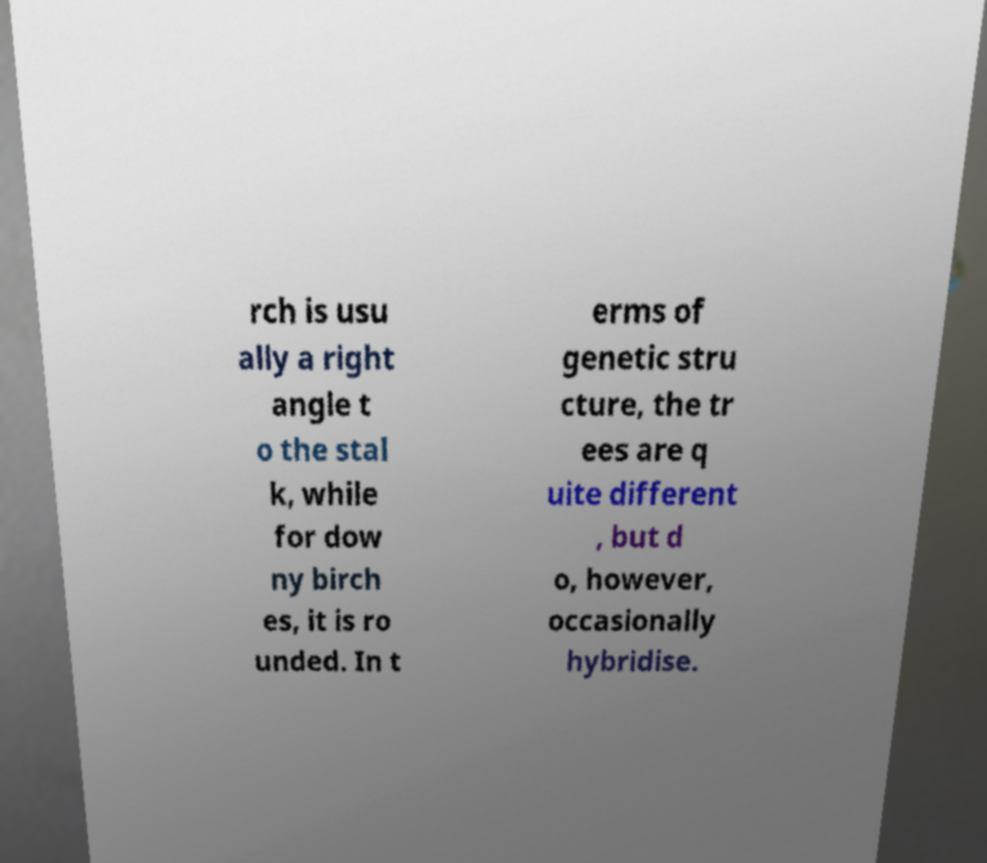For documentation purposes, I need the text within this image transcribed. Could you provide that? rch is usu ally a right angle t o the stal k, while for dow ny birch es, it is ro unded. In t erms of genetic stru cture, the tr ees are q uite different , but d o, however, occasionally hybridise. 